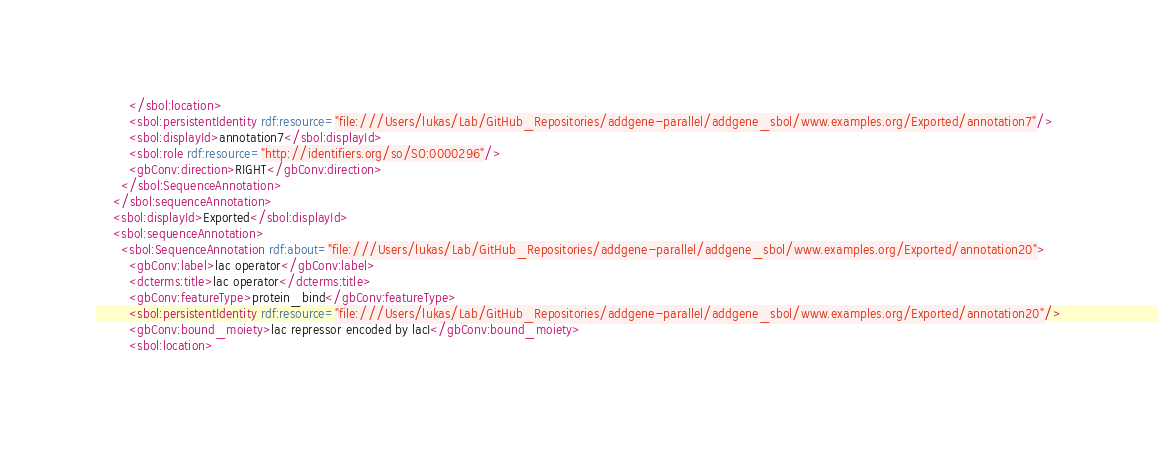Convert code to text. <code><loc_0><loc_0><loc_500><loc_500><_XML_>        </sbol:location>
        <sbol:persistentIdentity rdf:resource="file:///Users/lukas/Lab/GitHub_Repositories/addgene-parallel/addgene_sbol/www.examples.org/Exported/annotation7"/>
        <sbol:displayId>annotation7</sbol:displayId>
        <sbol:role rdf:resource="http://identifiers.org/so/SO:0000296"/>
        <gbConv:direction>RIGHT</gbConv:direction>
      </sbol:SequenceAnnotation>
    </sbol:sequenceAnnotation>
    <sbol:displayId>Exported</sbol:displayId>
    <sbol:sequenceAnnotation>
      <sbol:SequenceAnnotation rdf:about="file:///Users/lukas/Lab/GitHub_Repositories/addgene-parallel/addgene_sbol/www.examples.org/Exported/annotation20">
        <gbConv:label>lac operator</gbConv:label>
        <dcterms:title>lac operator</dcterms:title>
        <gbConv:featureType>protein_bind</gbConv:featureType>
        <sbol:persistentIdentity rdf:resource="file:///Users/lukas/Lab/GitHub_Repositories/addgene-parallel/addgene_sbol/www.examples.org/Exported/annotation20"/>
        <gbConv:bound_moiety>lac repressor encoded by lacI</gbConv:bound_moiety>
        <sbol:location></code> 